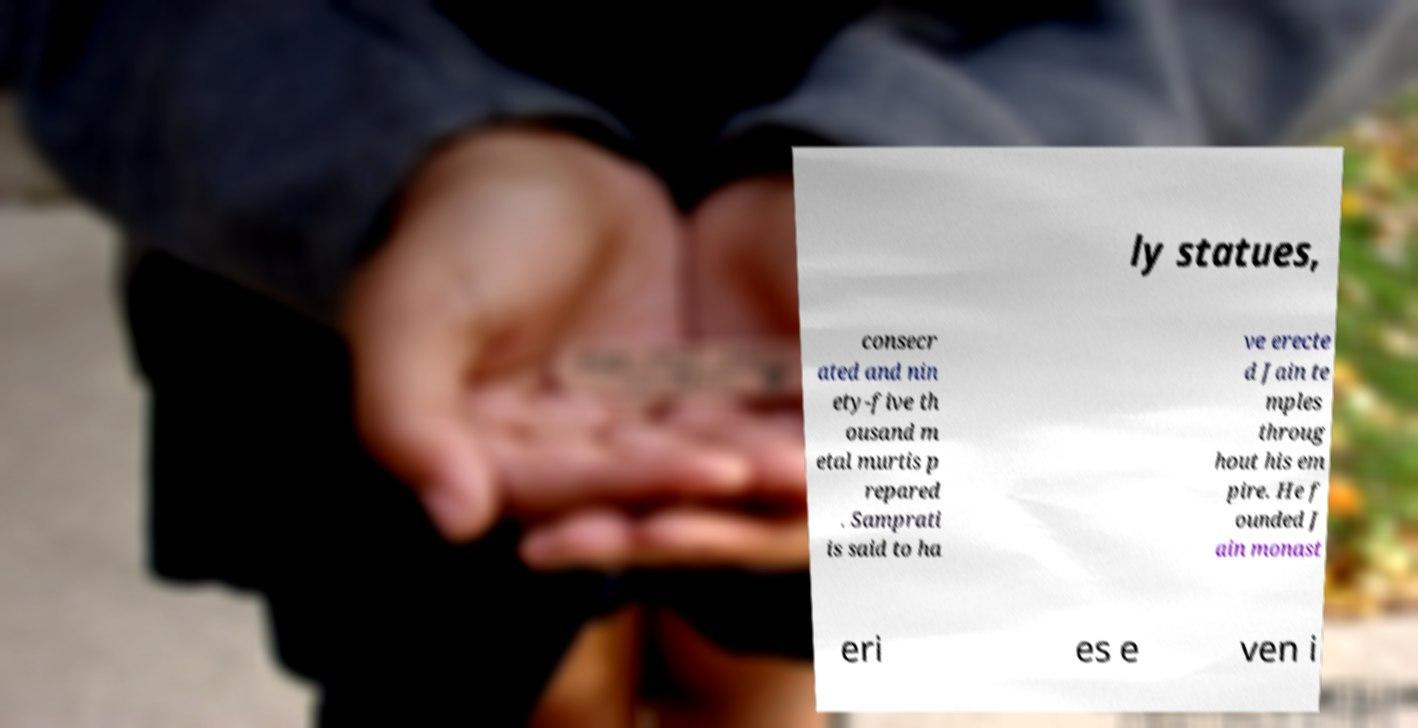Could you assist in decoding the text presented in this image and type it out clearly? ly statues, consecr ated and nin ety-five th ousand m etal murtis p repared . Samprati is said to ha ve erecte d Jain te mples throug hout his em pire. He f ounded J ain monast eri es e ven i 